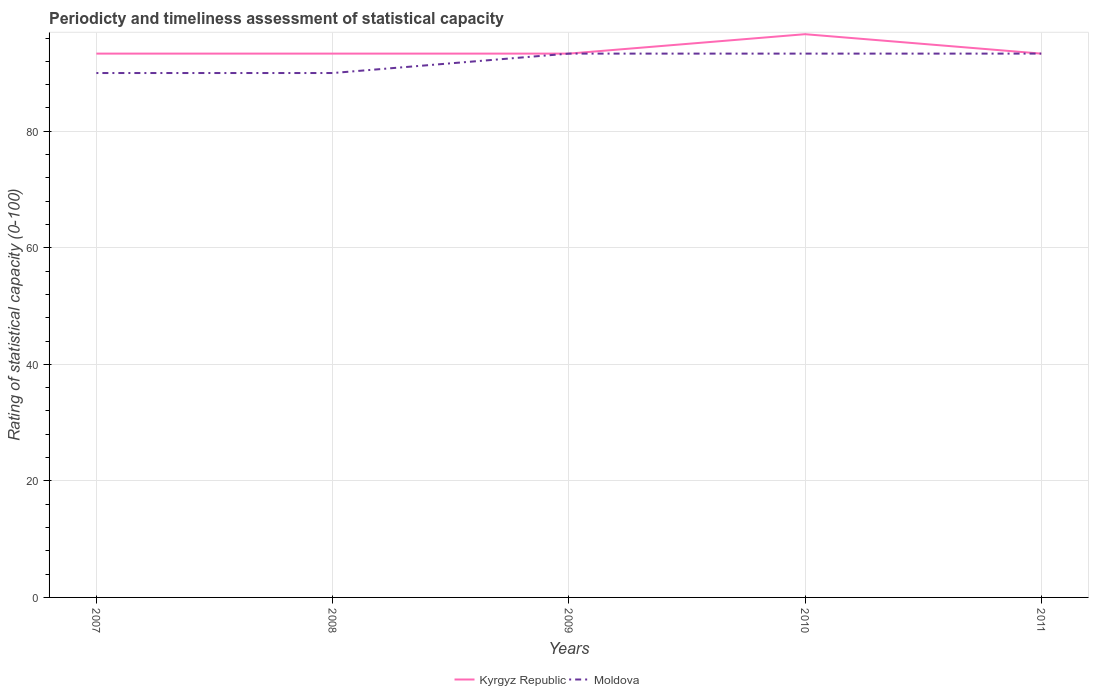Across all years, what is the maximum rating of statistical capacity in Kyrgyz Republic?
Your answer should be compact. 93.33. In which year was the rating of statistical capacity in Kyrgyz Republic maximum?
Make the answer very short. 2007. What is the total rating of statistical capacity in Moldova in the graph?
Give a very brief answer. -3.33. What is the difference between the highest and the second highest rating of statistical capacity in Kyrgyz Republic?
Provide a short and direct response. 3.33. Is the rating of statistical capacity in Kyrgyz Republic strictly greater than the rating of statistical capacity in Moldova over the years?
Your answer should be very brief. No. What is the difference between two consecutive major ticks on the Y-axis?
Ensure brevity in your answer.  20. Are the values on the major ticks of Y-axis written in scientific E-notation?
Your answer should be very brief. No. Does the graph contain any zero values?
Give a very brief answer. No. Where does the legend appear in the graph?
Your response must be concise. Bottom center. How many legend labels are there?
Offer a terse response. 2. How are the legend labels stacked?
Your response must be concise. Horizontal. What is the title of the graph?
Provide a succinct answer. Periodicty and timeliness assessment of statistical capacity. What is the label or title of the Y-axis?
Offer a terse response. Rating of statistical capacity (0-100). What is the Rating of statistical capacity (0-100) in Kyrgyz Republic in 2007?
Ensure brevity in your answer.  93.33. What is the Rating of statistical capacity (0-100) of Kyrgyz Republic in 2008?
Your response must be concise. 93.33. What is the Rating of statistical capacity (0-100) in Moldova in 2008?
Your answer should be compact. 90. What is the Rating of statistical capacity (0-100) of Kyrgyz Republic in 2009?
Your response must be concise. 93.33. What is the Rating of statistical capacity (0-100) of Moldova in 2009?
Your answer should be compact. 93.33. What is the Rating of statistical capacity (0-100) in Kyrgyz Republic in 2010?
Give a very brief answer. 96.67. What is the Rating of statistical capacity (0-100) in Moldova in 2010?
Offer a very short reply. 93.33. What is the Rating of statistical capacity (0-100) of Kyrgyz Republic in 2011?
Provide a succinct answer. 93.33. What is the Rating of statistical capacity (0-100) of Moldova in 2011?
Make the answer very short. 93.33. Across all years, what is the maximum Rating of statistical capacity (0-100) in Kyrgyz Republic?
Make the answer very short. 96.67. Across all years, what is the maximum Rating of statistical capacity (0-100) of Moldova?
Your response must be concise. 93.33. Across all years, what is the minimum Rating of statistical capacity (0-100) of Kyrgyz Republic?
Keep it short and to the point. 93.33. What is the total Rating of statistical capacity (0-100) in Kyrgyz Republic in the graph?
Ensure brevity in your answer.  470. What is the total Rating of statistical capacity (0-100) in Moldova in the graph?
Give a very brief answer. 460. What is the difference between the Rating of statistical capacity (0-100) of Kyrgyz Republic in 2007 and that in 2010?
Your response must be concise. -3.33. What is the difference between the Rating of statistical capacity (0-100) in Kyrgyz Republic in 2007 and that in 2011?
Your answer should be compact. 0. What is the difference between the Rating of statistical capacity (0-100) in Moldova in 2007 and that in 2011?
Ensure brevity in your answer.  -3.33. What is the difference between the Rating of statistical capacity (0-100) of Moldova in 2008 and that in 2010?
Offer a terse response. -3.33. What is the difference between the Rating of statistical capacity (0-100) of Kyrgyz Republic in 2008 and that in 2011?
Provide a short and direct response. 0. What is the difference between the Rating of statistical capacity (0-100) in Moldova in 2008 and that in 2011?
Make the answer very short. -3.33. What is the difference between the Rating of statistical capacity (0-100) in Kyrgyz Republic in 2009 and that in 2011?
Your response must be concise. 0. What is the difference between the Rating of statistical capacity (0-100) in Moldova in 2009 and that in 2011?
Your answer should be very brief. 0. What is the difference between the Rating of statistical capacity (0-100) of Kyrgyz Republic in 2007 and the Rating of statistical capacity (0-100) of Moldova in 2008?
Give a very brief answer. 3.33. What is the difference between the Rating of statistical capacity (0-100) of Kyrgyz Republic in 2007 and the Rating of statistical capacity (0-100) of Moldova in 2009?
Your answer should be compact. 0. What is the difference between the Rating of statistical capacity (0-100) in Kyrgyz Republic in 2007 and the Rating of statistical capacity (0-100) in Moldova in 2010?
Make the answer very short. 0. What is the difference between the Rating of statistical capacity (0-100) of Kyrgyz Republic in 2008 and the Rating of statistical capacity (0-100) of Moldova in 2009?
Ensure brevity in your answer.  0. What is the difference between the Rating of statistical capacity (0-100) in Kyrgyz Republic in 2008 and the Rating of statistical capacity (0-100) in Moldova in 2011?
Provide a short and direct response. 0. What is the difference between the Rating of statistical capacity (0-100) of Kyrgyz Republic in 2009 and the Rating of statistical capacity (0-100) of Moldova in 2010?
Offer a very short reply. 0. What is the average Rating of statistical capacity (0-100) in Kyrgyz Republic per year?
Provide a succinct answer. 94. What is the average Rating of statistical capacity (0-100) of Moldova per year?
Offer a terse response. 92. In the year 2007, what is the difference between the Rating of statistical capacity (0-100) of Kyrgyz Republic and Rating of statistical capacity (0-100) of Moldova?
Make the answer very short. 3.33. In the year 2008, what is the difference between the Rating of statistical capacity (0-100) of Kyrgyz Republic and Rating of statistical capacity (0-100) of Moldova?
Provide a succinct answer. 3.33. In the year 2010, what is the difference between the Rating of statistical capacity (0-100) in Kyrgyz Republic and Rating of statistical capacity (0-100) in Moldova?
Your response must be concise. 3.33. In the year 2011, what is the difference between the Rating of statistical capacity (0-100) of Kyrgyz Republic and Rating of statistical capacity (0-100) of Moldova?
Your answer should be compact. 0. What is the ratio of the Rating of statistical capacity (0-100) in Moldova in 2007 to that in 2008?
Your answer should be very brief. 1. What is the ratio of the Rating of statistical capacity (0-100) in Kyrgyz Republic in 2007 to that in 2009?
Your answer should be compact. 1. What is the ratio of the Rating of statistical capacity (0-100) in Moldova in 2007 to that in 2009?
Offer a very short reply. 0.96. What is the ratio of the Rating of statistical capacity (0-100) of Kyrgyz Republic in 2007 to that in 2010?
Offer a terse response. 0.97. What is the ratio of the Rating of statistical capacity (0-100) in Kyrgyz Republic in 2007 to that in 2011?
Your answer should be compact. 1. What is the ratio of the Rating of statistical capacity (0-100) of Moldova in 2007 to that in 2011?
Your response must be concise. 0.96. What is the ratio of the Rating of statistical capacity (0-100) of Moldova in 2008 to that in 2009?
Ensure brevity in your answer.  0.96. What is the ratio of the Rating of statistical capacity (0-100) in Kyrgyz Republic in 2008 to that in 2010?
Make the answer very short. 0.97. What is the ratio of the Rating of statistical capacity (0-100) of Kyrgyz Republic in 2009 to that in 2010?
Your answer should be compact. 0.97. What is the ratio of the Rating of statistical capacity (0-100) in Kyrgyz Republic in 2010 to that in 2011?
Offer a very short reply. 1.04. What is the difference between the highest and the second highest Rating of statistical capacity (0-100) in Kyrgyz Republic?
Your answer should be compact. 3.33. What is the difference between the highest and the lowest Rating of statistical capacity (0-100) in Kyrgyz Republic?
Offer a terse response. 3.33. What is the difference between the highest and the lowest Rating of statistical capacity (0-100) of Moldova?
Offer a terse response. 3.33. 